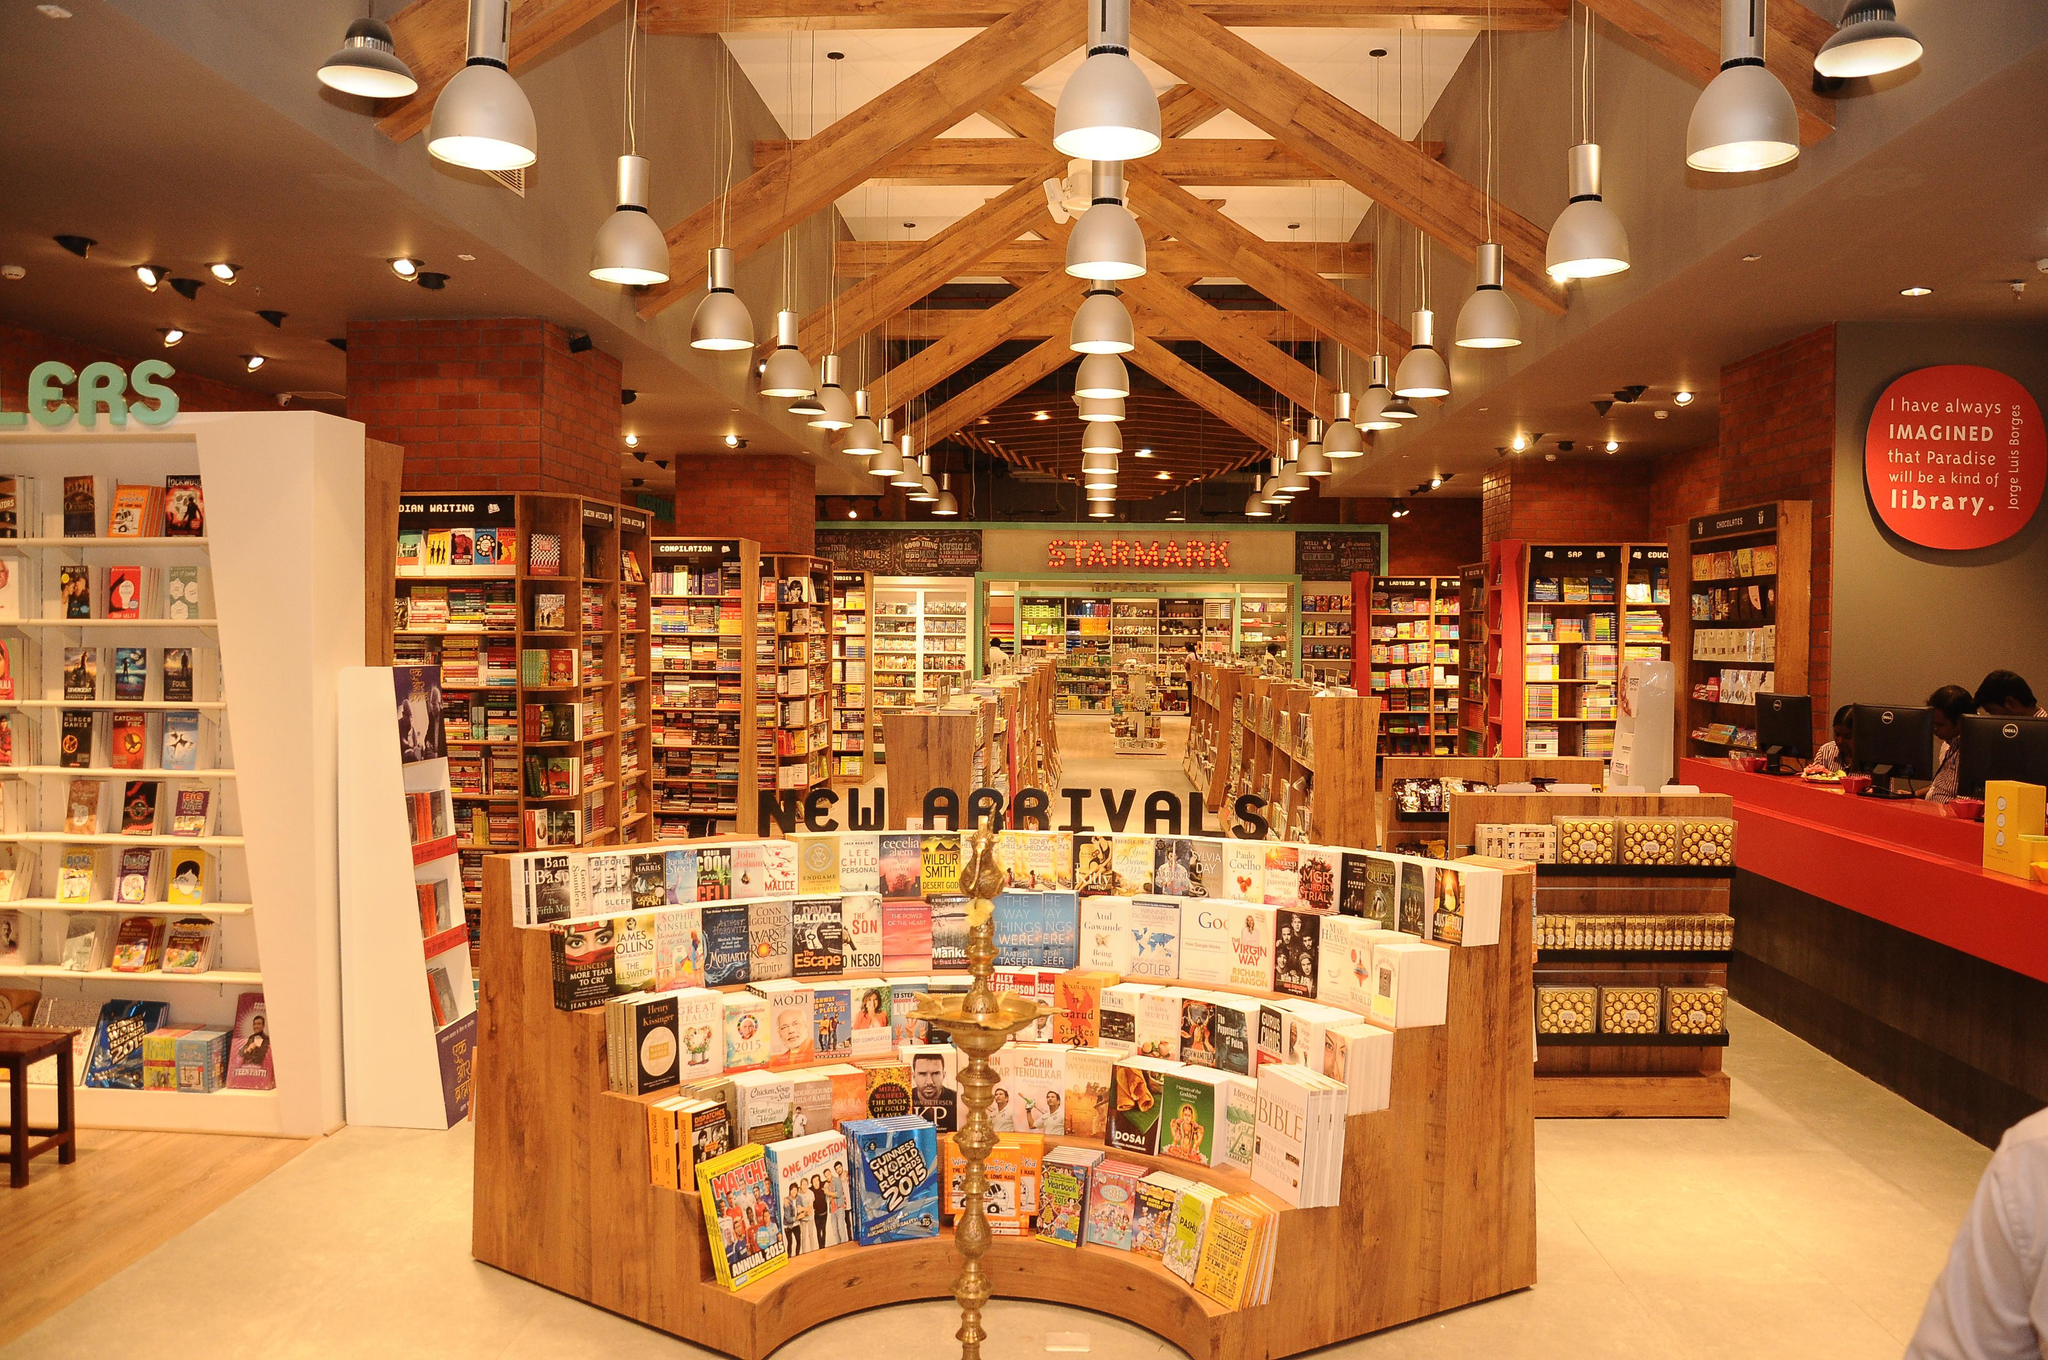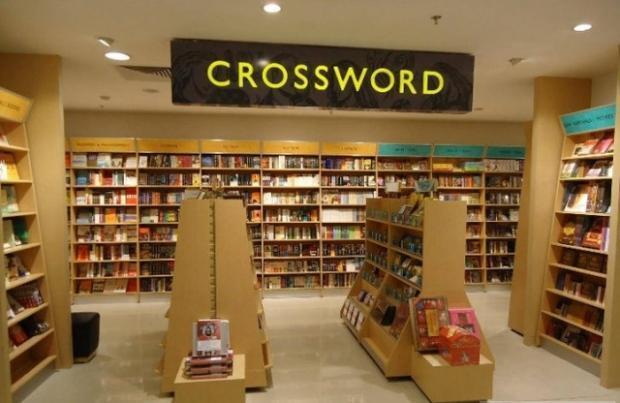The first image is the image on the left, the second image is the image on the right. Assess this claim about the two images: "One bookshop interior features a dimensional tiered display of books in front of aisles of book shelves and an exposed beam ceiling with dome-shaped lights.". Correct or not? Answer yes or no. Yes. 